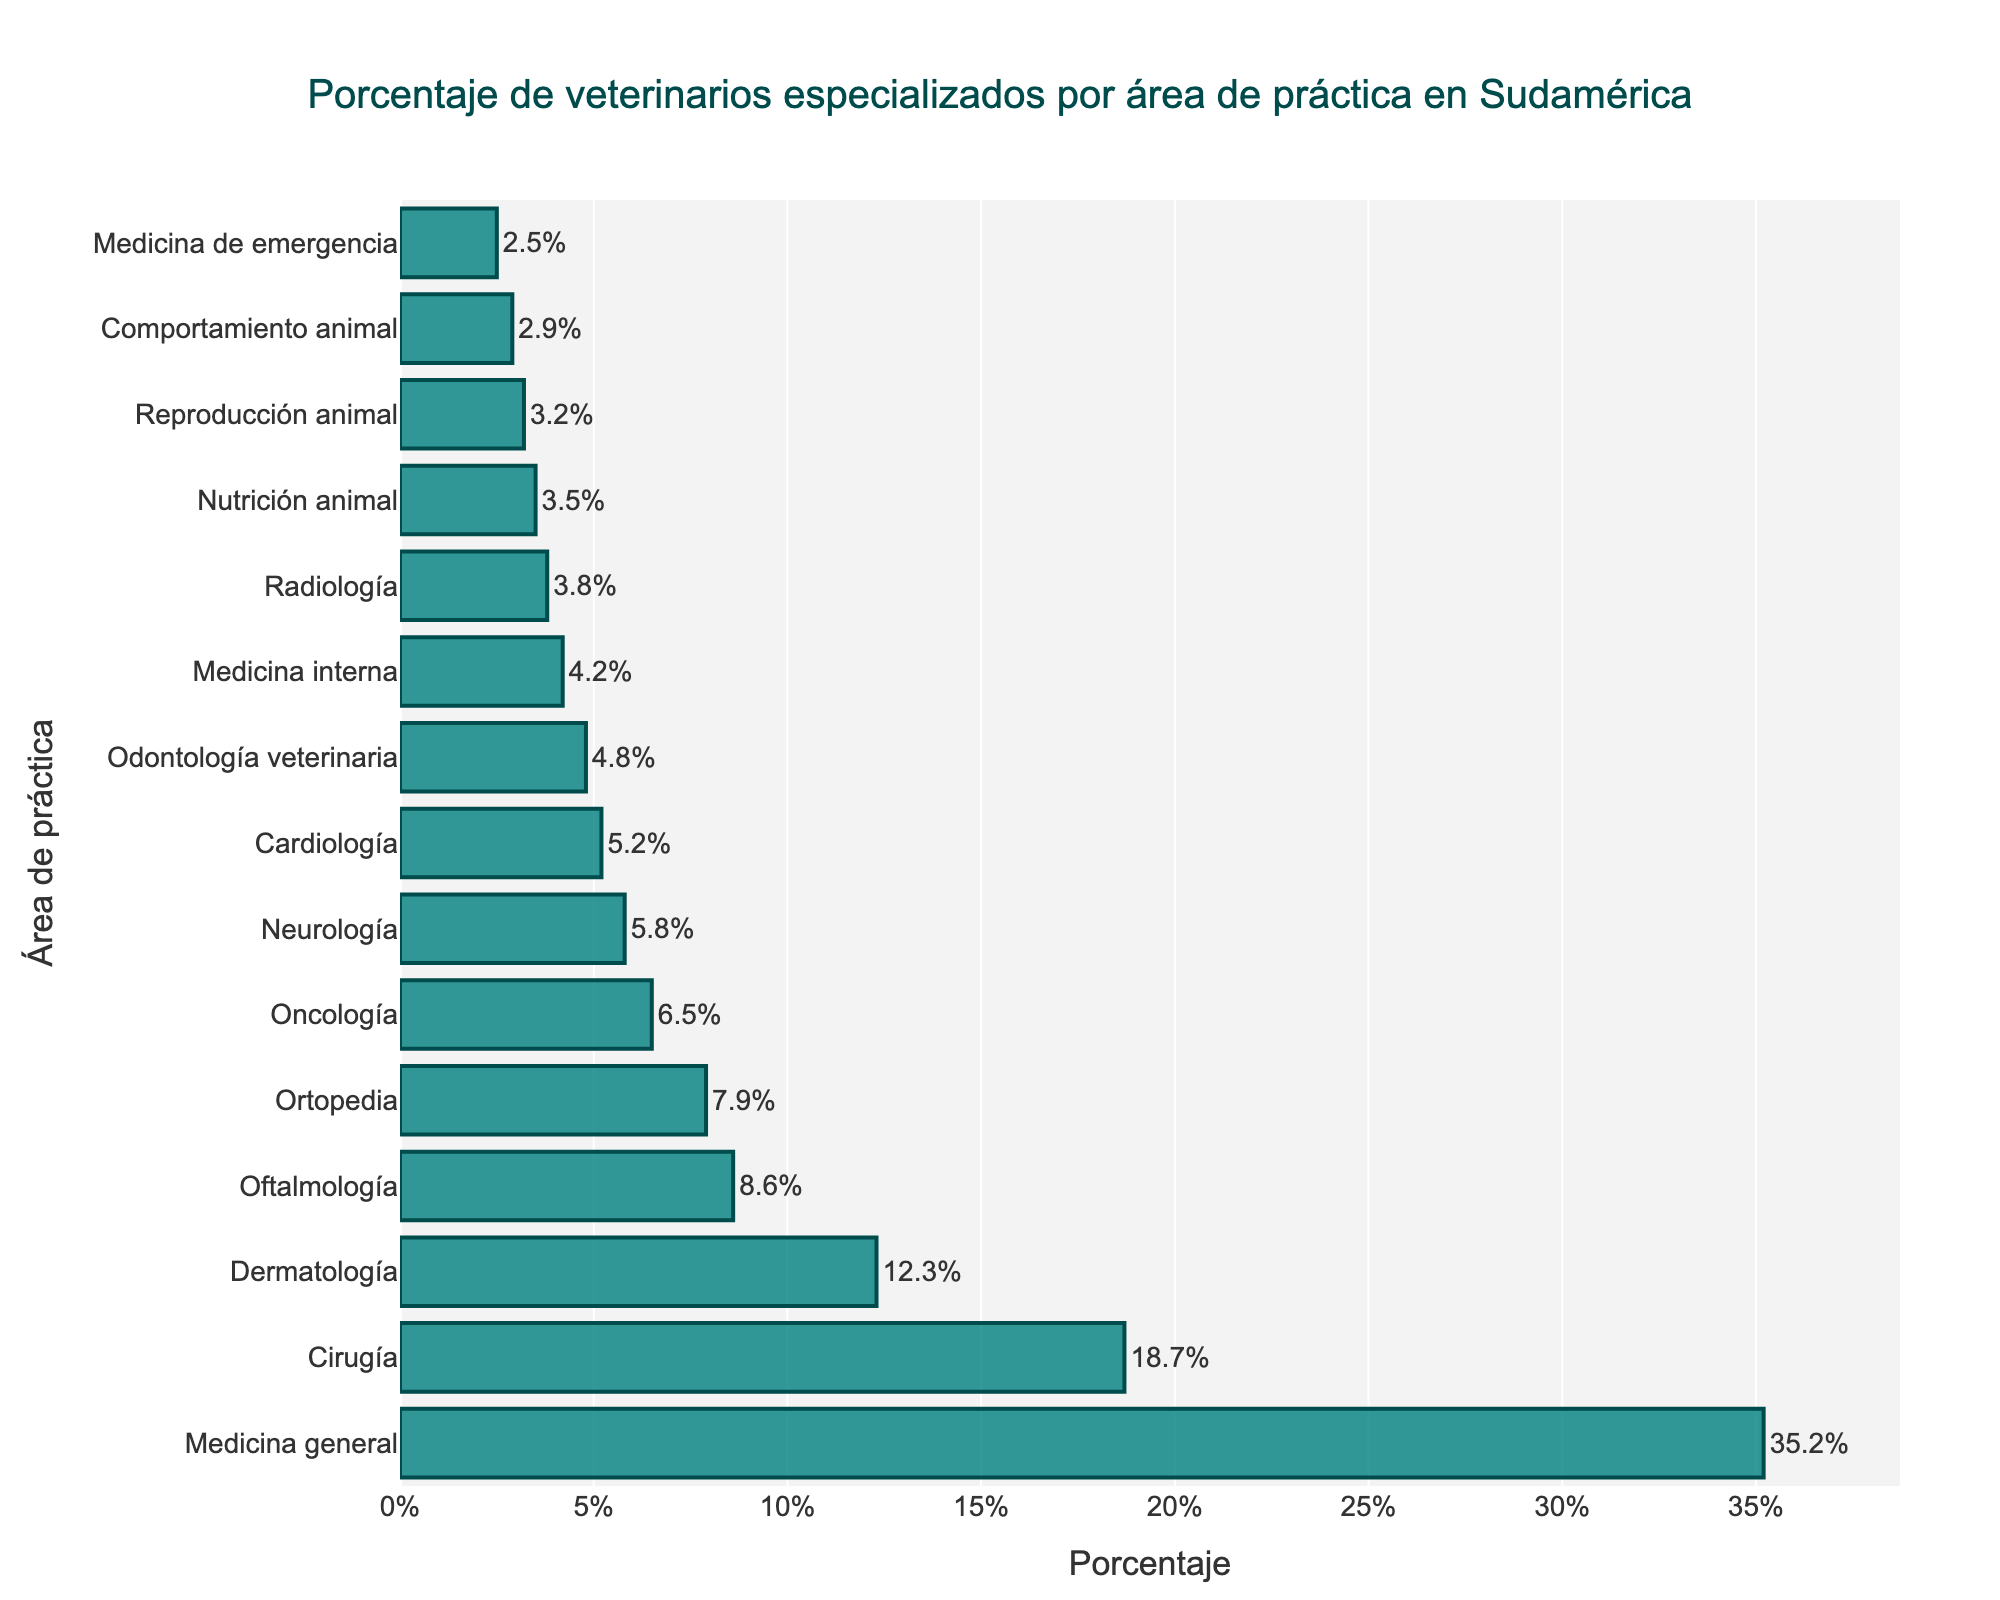¿Cuál es el área de práctica con el mayor porcentaje de veterinarios especializados en Sudamérica? La barra más alta del gráfico representa el área de práctica con el mayor porcentaje de veterinarios especializados. En este caso, la más alta corresponde a Medicina general con un 35.2%.
Answer: Medicina general ¿Cuántas áreas de práctica tienen un porcentaje de veterinarios especializados mayor que 10%? Al observar las barras del gráfico, identificamos que Medicina general, Cirugía y Dermatología tienen un porcentaje mayor que 10%. Eso hace un total de 3 áreas.
Answer: 3 ¿Cuál es la diferencia en porcentaje entre los veterinarios especializados en Dermatología y los especializados en Oftalmología? El porcentaje de Dermatología es 12.3% y el de Oftalmología es 8.6%. La diferencia se calcula restando 8.6 de 12.3, que da como resultado 3.7%.
Answer: 3.7% ¿Qué áreas de práctica combinadas comprenden cerca del 20% del total de veterinarios especializados? Sumamos los porcentajes de las áreas más pequeñas hasta conseguir cerca del 20%. Odontología veterinaria (4.8%) + Medicina interna (4.2%) + Radiología (3.8%) + Nutrición animal (3.5%) + Reproducción animal (3.2%) = 19.5%.
Answer: Odontología veterinaria, Medicina interna, Radiología, Nutrición animal, Reproducción animal ¿Es mayor el porcentaje de veterinarios especializados en Cardiología que en Neurología? Comparando las longitudes de las barras de Cardiología y Neurología, vemos que el valor de Cardiología es 5.2% y el de Neurología es 5.8%. Por lo tanto, Neurología tiene un mayor porcentaje.
Answer: No ¿Qué porcentaje del total de veterinarios especializados representa Cirugía y Oncología juntos? Sumamos los porcentajes de ambas áreas: Cirugía (18.7%) + Oncología (6.5%) = 25.2%.
Answer: 25.2% ¿Cuál es el área de práctica con el menor porcentaje de veterinarios especializados? La barra más baja del gráfico representa el área de práctica con el menor porcentaje. En este caso, corresponde a Medicina de emergencia con un 2.5%.
Answer: Medicina de emergencia ¿Cuántas áreas de práctica tienen un porcentaje menor al 5% de veterinarios especializados? Contando las barras con valores menores al 5%, encontramos Cardiología (5.2%), Odontología veterinaria (4.8%), Medicina interna (4.2%), Radiología (3.8%), Nutrición animal (3.5%), Reproducción animal (3.2%), Comportamiento animal (2.9%), y Medicina de emergencia (2.5%). Entonces, hay 8 áreas.
Answer: 8 ¿Cuál es la cuarta área de práctica con mayor porcentaje de veterinarios especializados? Ordenando las barras por tamaño, la cuarta más alta corresponde a Oftalmología con un 8.6%.
Answer: Oftalmología 